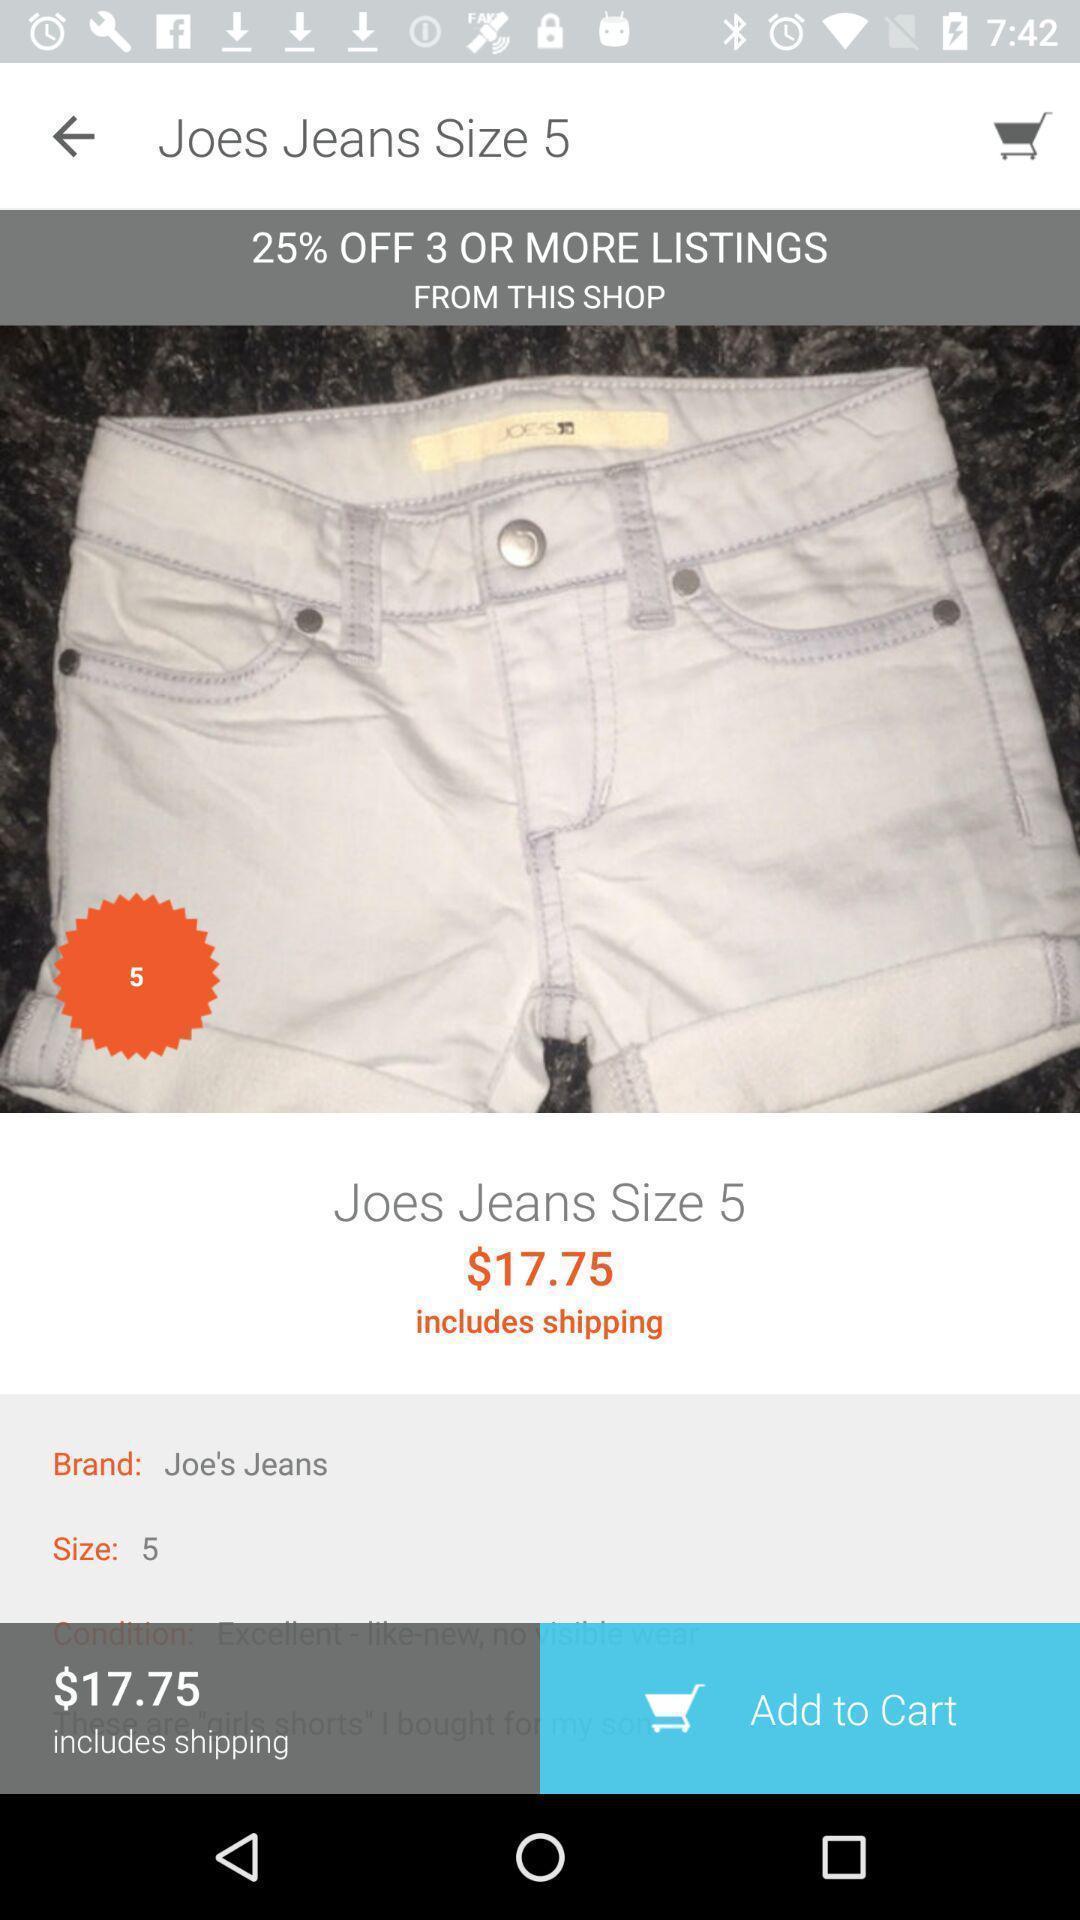Tell me about the visual elements in this screen capture. Screen page of a shopping app. 